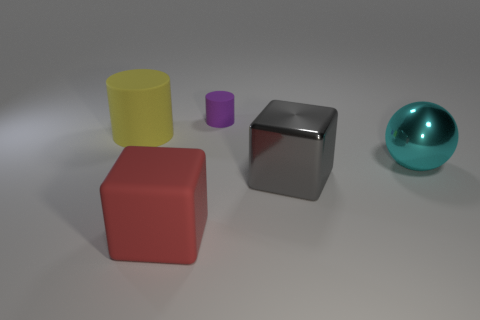Are there any other things that have the same size as the purple matte cylinder?
Your answer should be compact. No. The matte object in front of the large matte object left of the block that is left of the gray metal block is what color?
Offer a terse response. Red. There is a red thing; is its shape the same as the gray object in front of the big matte cylinder?
Your answer should be compact. Yes. The object that is on the left side of the small purple thing and behind the gray object is what color?
Your answer should be very brief. Yellow. Are there any other things of the same shape as the large gray shiny object?
Keep it short and to the point. Yes. There is a tiny matte thing behind the big cyan thing; is there a red block on the left side of it?
Give a very brief answer. Yes. What number of things are objects on the right side of the yellow matte object or things in front of the tiny matte thing?
Keep it short and to the point. 5. What number of objects are either shiny blocks or big metallic objects that are in front of the cyan thing?
Ensure brevity in your answer.  1. What size is the rubber thing left of the large matte object that is in front of the big thing right of the large metal block?
Keep it short and to the point. Large. What material is the yellow thing that is the same size as the red object?
Provide a succinct answer. Rubber. 